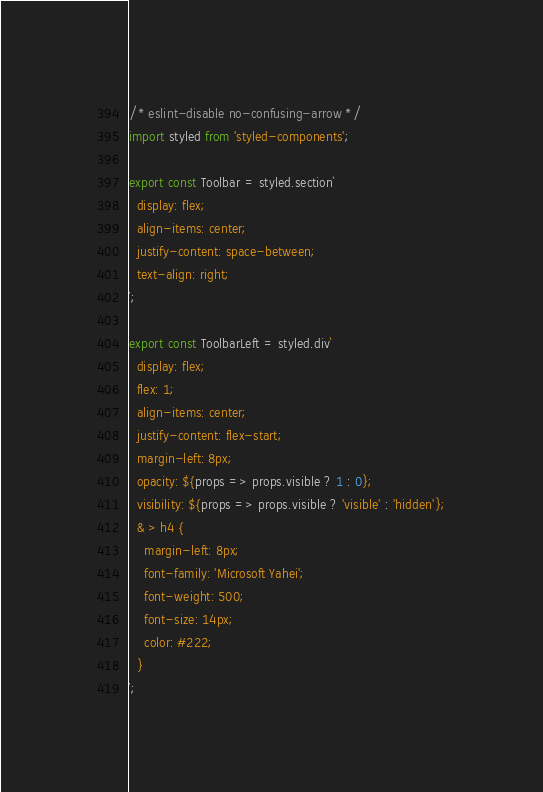<code> <loc_0><loc_0><loc_500><loc_500><_JavaScript_>/* eslint-disable no-confusing-arrow */
import styled from 'styled-components';

export const Toolbar = styled.section`
  display: flex;
  align-items: center;
  justify-content: space-between;
  text-align: right;
`;

export const ToolbarLeft = styled.div`
  display: flex;
  flex: 1;
  align-items: center;
  justify-content: flex-start;
  margin-left: 8px;
  opacity: ${props => props.visible ? 1 : 0};
  visibility: ${props => props.visible ? 'visible' : 'hidden'};
  & > h4 {
    margin-left: 8px;
    font-family: 'Microsoft Yahei';
    font-weight: 500;
    font-size: 14px;
    color: #222;
  }
`;
</code> 